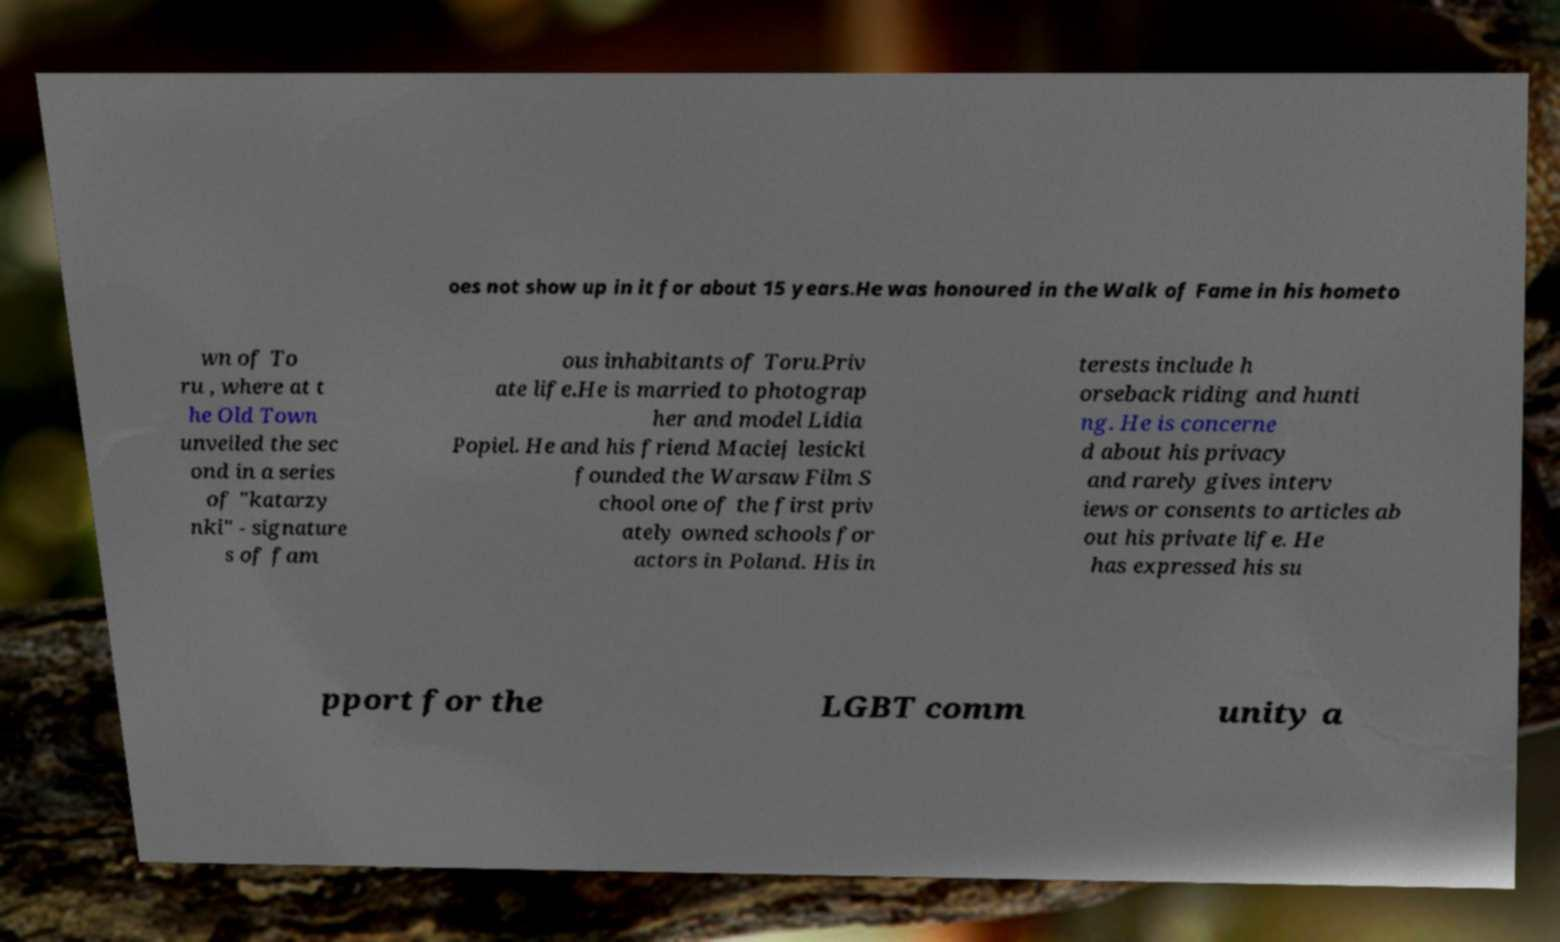There's text embedded in this image that I need extracted. Can you transcribe it verbatim? oes not show up in it for about 15 years.He was honoured in the Walk of Fame in his hometo wn of To ru , where at t he Old Town unveiled the sec ond in a series of "katarzy nki" - signature s of fam ous inhabitants of Toru.Priv ate life.He is married to photograp her and model Lidia Popiel. He and his friend Maciej lesicki founded the Warsaw Film S chool one of the first priv ately owned schools for actors in Poland. His in terests include h orseback riding and hunti ng. He is concerne d about his privacy and rarely gives interv iews or consents to articles ab out his private life. He has expressed his su pport for the LGBT comm unity a 